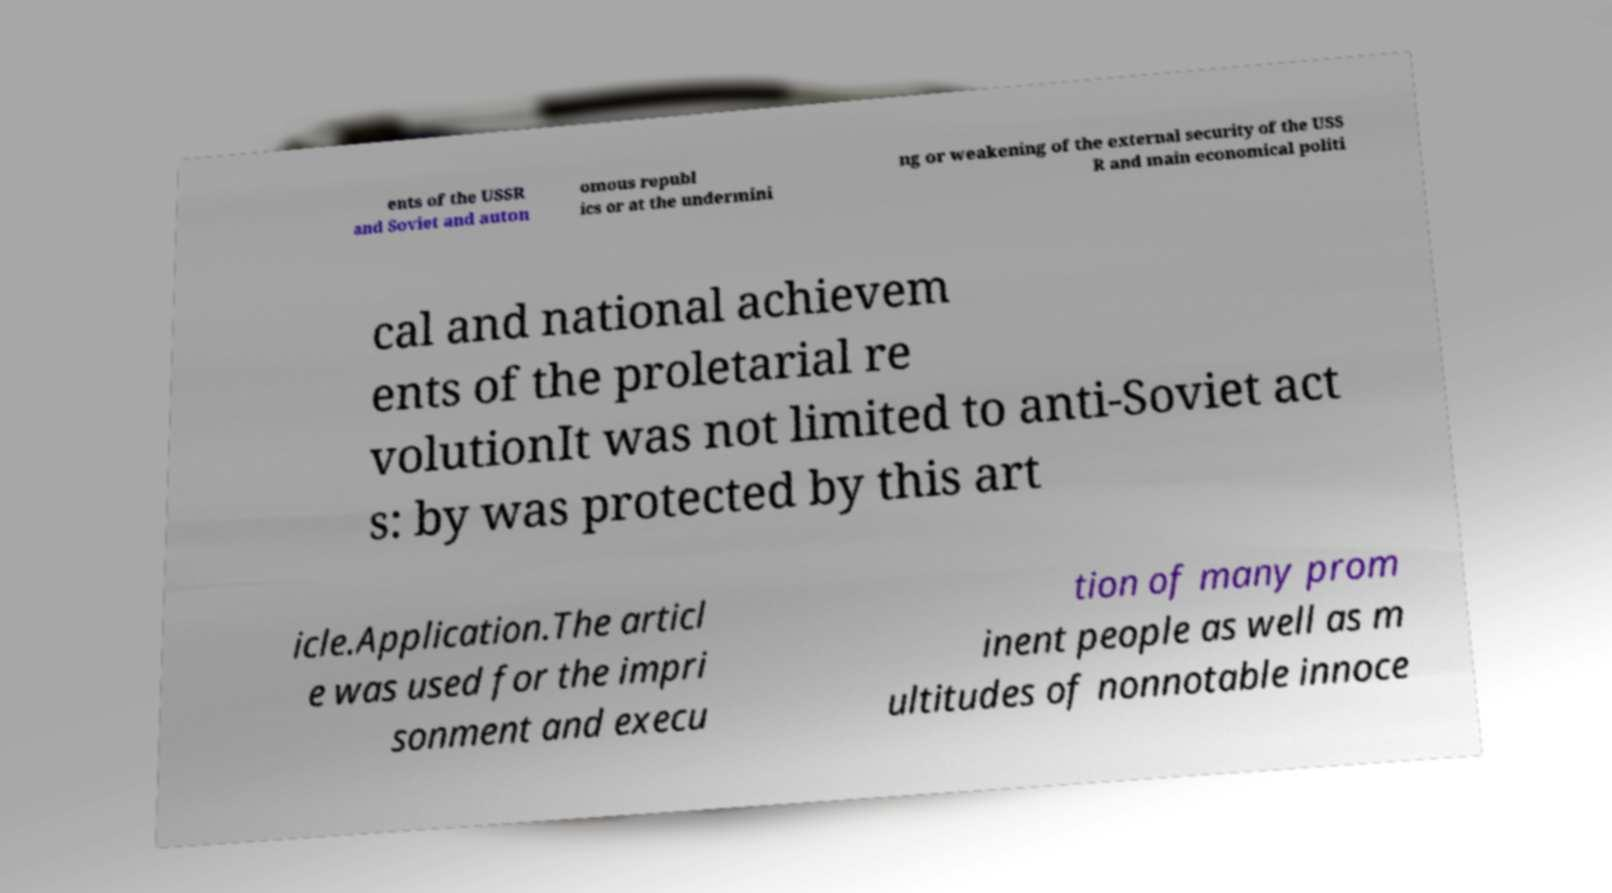Can you read and provide the text displayed in the image?This photo seems to have some interesting text. Can you extract and type it out for me? ents of the USSR and Soviet and auton omous republ ics or at the undermini ng or weakening of the external security of the USS R and main economical politi cal and national achievem ents of the proletarial re volutionIt was not limited to anti-Soviet act s: by was protected by this art icle.Application.The articl e was used for the impri sonment and execu tion of many prom inent people as well as m ultitudes of nonnotable innoce 